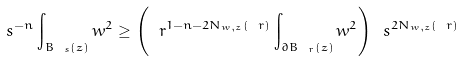Convert formula to latex. <formula><loc_0><loc_0><loc_500><loc_500>\ s ^ { - n } \int _ { B _ { \ s } ( z ) } w ^ { 2 } \geq \left ( \ r ^ { 1 - n - 2 N _ { w , z } ( \ r ) } \int _ { \partial B _ { \ r } ( z ) } w ^ { 2 } \right ) \ s ^ { 2 N _ { w , z } ( \ r ) }</formula> 